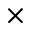<formula> <loc_0><loc_0><loc_500><loc_500>\times</formula> 